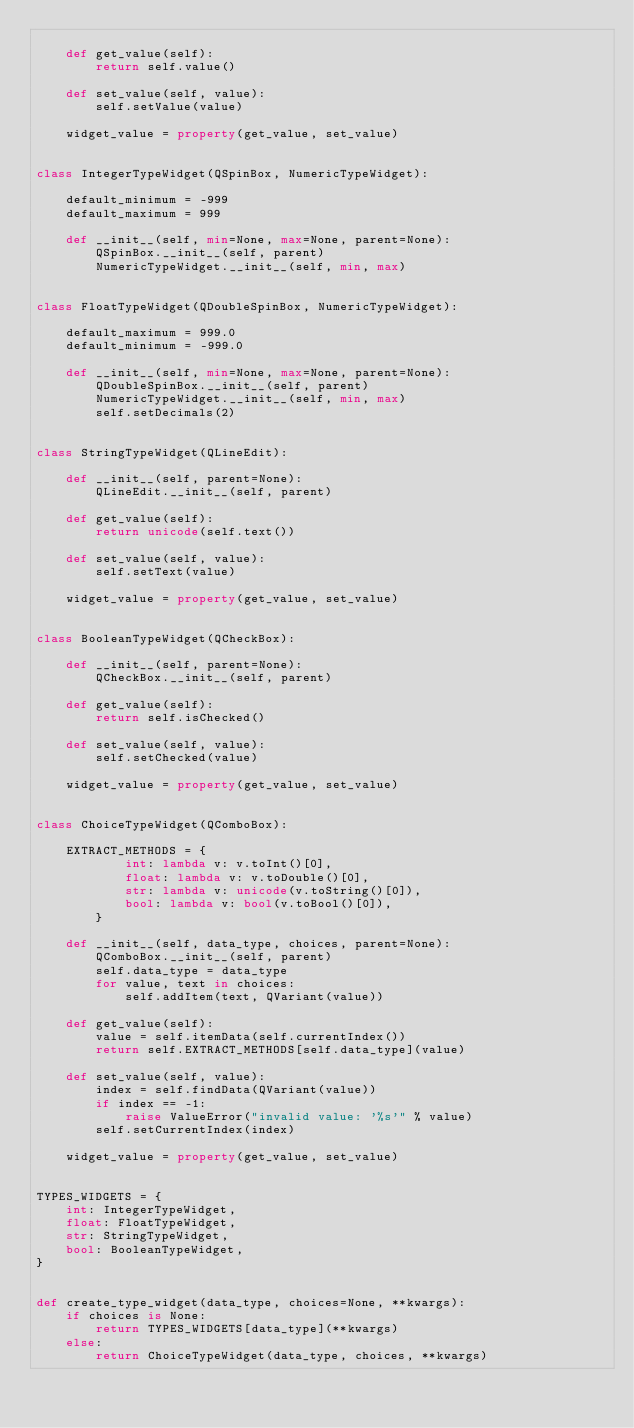<code> <loc_0><loc_0><loc_500><loc_500><_Python_>
    def get_value(self):
        return self.value()

    def set_value(self, value):
        self.setValue(value)

    widget_value = property(get_value, set_value)


class IntegerTypeWidget(QSpinBox, NumericTypeWidget):

    default_minimum = -999
    default_maximum = 999

    def __init__(self, min=None, max=None, parent=None):
        QSpinBox.__init__(self, parent)
        NumericTypeWidget.__init__(self, min, max)


class FloatTypeWidget(QDoubleSpinBox, NumericTypeWidget):

    default_maximum = 999.0
    default_minimum = -999.0

    def __init__(self, min=None, max=None, parent=None):
        QDoubleSpinBox.__init__(self, parent)
        NumericTypeWidget.__init__(self, min, max)
        self.setDecimals(2)


class StringTypeWidget(QLineEdit):

    def __init__(self, parent=None):
        QLineEdit.__init__(self, parent)

    def get_value(self):
        return unicode(self.text())

    def set_value(self, value):
        self.setText(value)

    widget_value = property(get_value, set_value)


class BooleanTypeWidget(QCheckBox):

    def __init__(self, parent=None):
        QCheckBox.__init__(self, parent)

    def get_value(self):
        return self.isChecked()

    def set_value(self, value):
        self.setChecked(value)

    widget_value = property(get_value, set_value)


class ChoiceTypeWidget(QComboBox):

    EXTRACT_METHODS = {
            int: lambda v: v.toInt()[0],
            float: lambda v: v.toDouble()[0],
            str: lambda v: unicode(v.toString()[0]),
            bool: lambda v: bool(v.toBool()[0]),
        }

    def __init__(self, data_type, choices, parent=None):
        QComboBox.__init__(self, parent)
        self.data_type = data_type
        for value, text in choices:
            self.addItem(text, QVariant(value))

    def get_value(self):
        value = self.itemData(self.currentIndex())
        return self.EXTRACT_METHODS[self.data_type](value)

    def set_value(self, value):
        index = self.findData(QVariant(value))
        if index == -1:
            raise ValueError("invalid value: '%s'" % value)
        self.setCurrentIndex(index)

    widget_value = property(get_value, set_value)


TYPES_WIDGETS = {
    int: IntegerTypeWidget,
    float: FloatTypeWidget,
    str: StringTypeWidget,
    bool: BooleanTypeWidget,
}


def create_type_widget(data_type, choices=None, **kwargs):
    if choices is None:
        return TYPES_WIDGETS[data_type](**kwargs)
    else:
        return ChoiceTypeWidget(data_type, choices, **kwargs)
</code> 